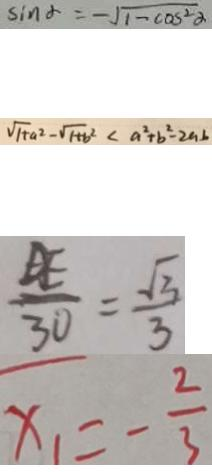<formula> <loc_0><loc_0><loc_500><loc_500>\sin \alpha = - \sqrt { 1 - \cos ^ { 2 } \alpha } 
 \sqrt { 1 + a ^ { 2 } } - \sqrt { 1 + b ^ { 2 } } < a ^ { 2 } + b ^ { 2 } - 2 a b 
 \frac { D E } { 3 0 } = \frac { \sqrt { 3 } } { 3 } 
 x _ { 1 } = - \frac { 2 } { 3 }</formula> 